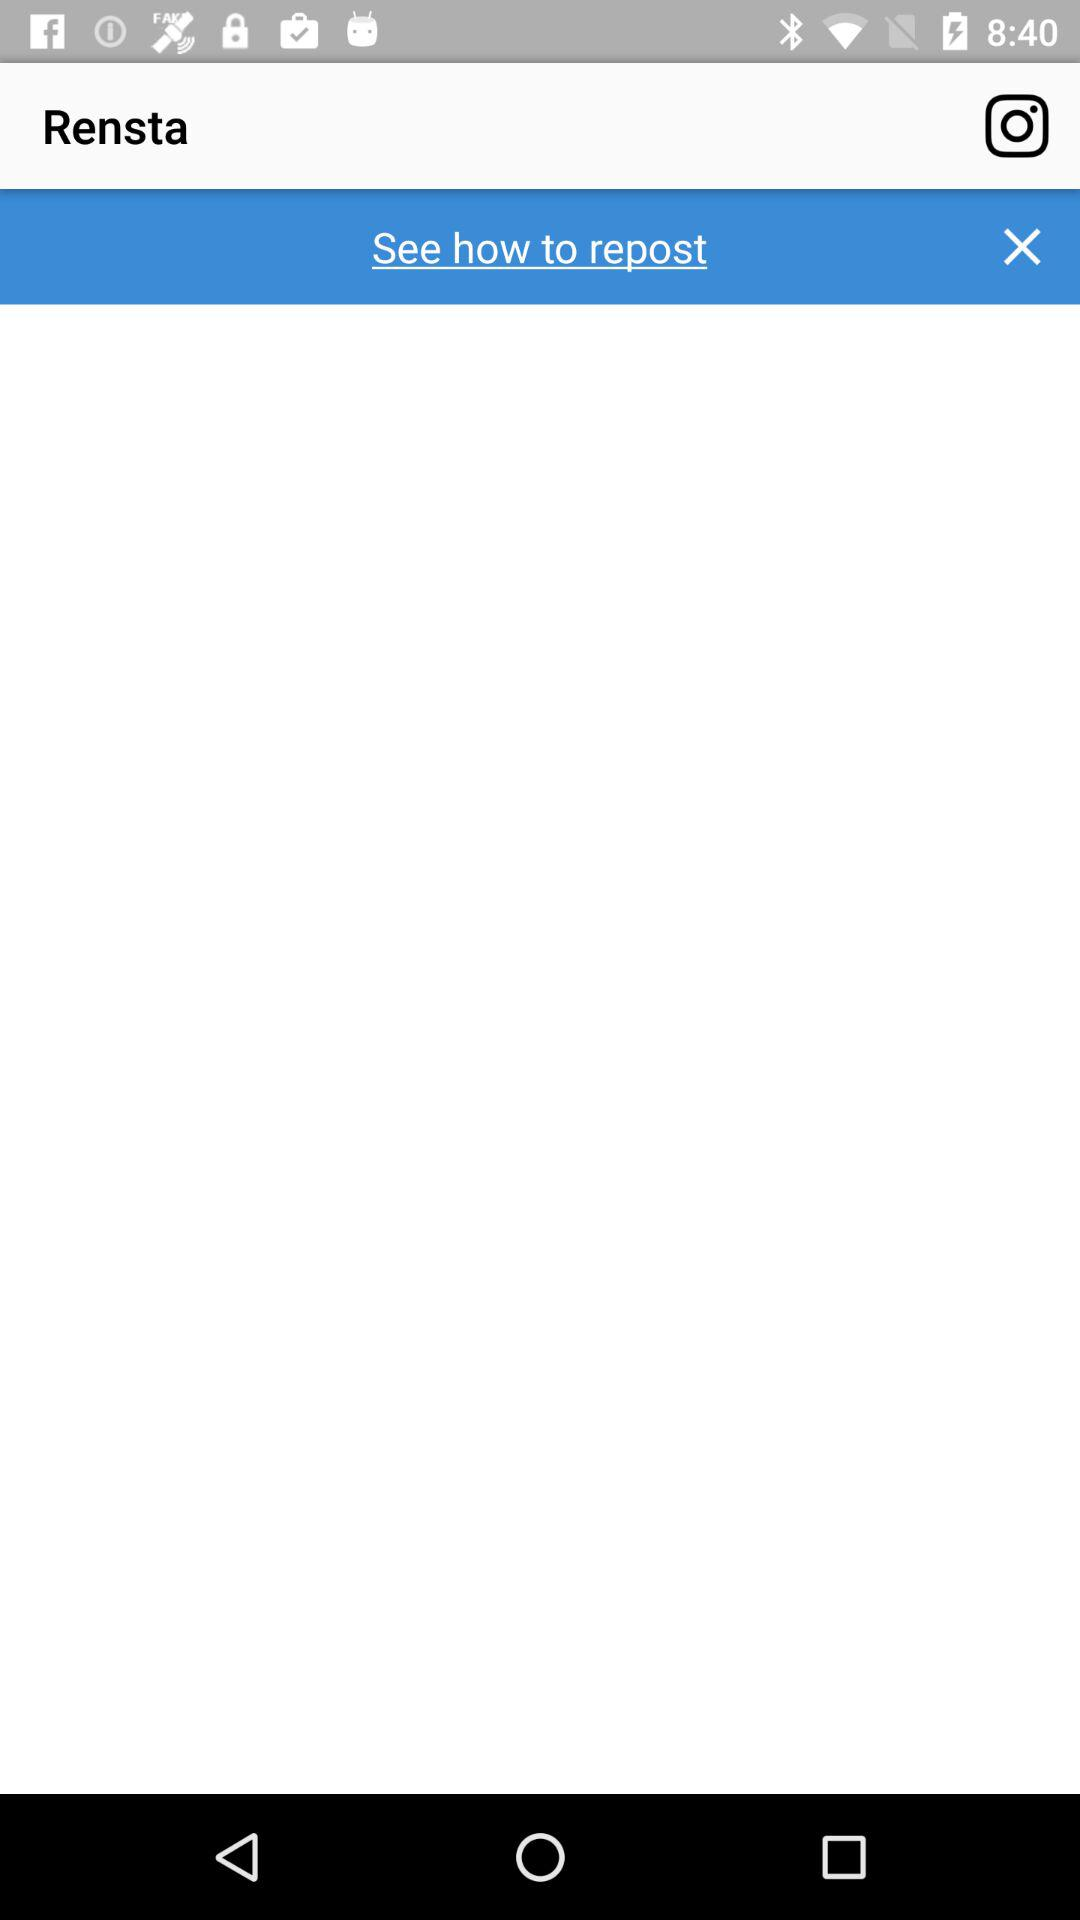What is the application name? The application name is "Rensta". 